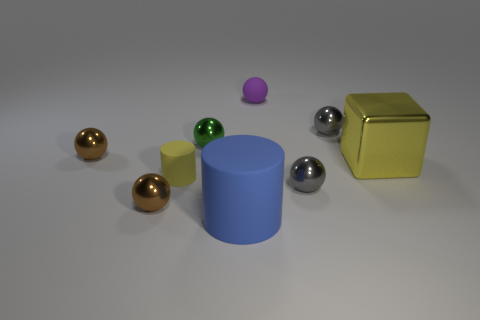Do the big metal object and the tiny matte cylinder have the same color?
Offer a terse response. Yes. What is the color of the ball that is to the left of the tiny green ball and behind the metallic cube?
Give a very brief answer. Brown. How many things are gray spheres that are behind the green ball or purple balls?
Provide a succinct answer. 2. The other small rubber object that is the same shape as the green object is what color?
Provide a succinct answer. Purple. Is the shape of the purple rubber object the same as the brown metallic object in front of the yellow metallic block?
Your response must be concise. Yes. How many objects are either small gray shiny balls that are behind the small green metal sphere or matte objects behind the big blue cylinder?
Provide a succinct answer. 3. Are there fewer green shiny objects right of the big block than big brown metallic cubes?
Make the answer very short. No. Are the small cylinder and the purple ball that is behind the large blue matte cylinder made of the same material?
Your response must be concise. Yes. What material is the large blue cylinder?
Ensure brevity in your answer.  Rubber. The tiny yellow object in front of the yellow object to the right of the large object that is on the left side of the big yellow metal object is made of what material?
Keep it short and to the point. Rubber. 